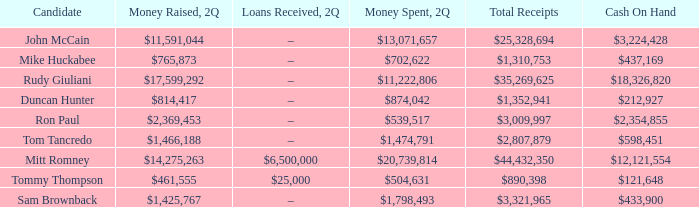Tell me the money raised when 2Q has total receipts of $890,398 $461,555. Can you parse all the data within this table? {'header': ['Candidate', 'Money Raised, 2Q', 'Loans Received, 2Q', 'Money Spent, 2Q', 'Total Receipts', 'Cash On Hand'], 'rows': [['John McCain', '$11,591,044', '–', '$13,071,657', '$25,328,694', '$3,224,428'], ['Mike Huckabee', '$765,873', '–', '$702,622', '$1,310,753', '$437,169'], ['Rudy Giuliani', '$17,599,292', '–', '$11,222,806', '$35,269,625', '$18,326,820'], ['Duncan Hunter', '$814,417', '–', '$874,042', '$1,352,941', '$212,927'], ['Ron Paul', '$2,369,453', '–', '$539,517', '$3,009,997', '$2,354,855'], ['Tom Tancredo', '$1,466,188', '–', '$1,474,791', '$2,807,879', '$598,451'], ['Mitt Romney', '$14,275,263', '$6,500,000', '$20,739,814', '$44,432,350', '$12,121,554'], ['Tommy Thompson', '$461,555', '$25,000', '$504,631', '$890,398', '$121,648'], ['Sam Brownback', '$1,425,767', '–', '$1,798,493', '$3,321,965', '$433,900']]} 